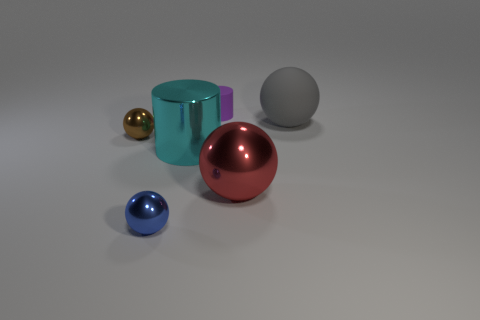Subtract all big red balls. How many balls are left? 3 Subtract all brown spheres. How many spheres are left? 3 Subtract 1 balls. How many balls are left? 3 Subtract all spheres. How many objects are left? 2 Subtract all yellow cylinders. Subtract all blue spheres. How many cylinders are left? 2 Add 1 matte spheres. How many matte spheres exist? 2 Add 1 small objects. How many objects exist? 7 Subtract 0 purple spheres. How many objects are left? 6 Subtract all green balls. How many purple cylinders are left? 1 Subtract all blue metallic balls. Subtract all small blue shiny objects. How many objects are left? 4 